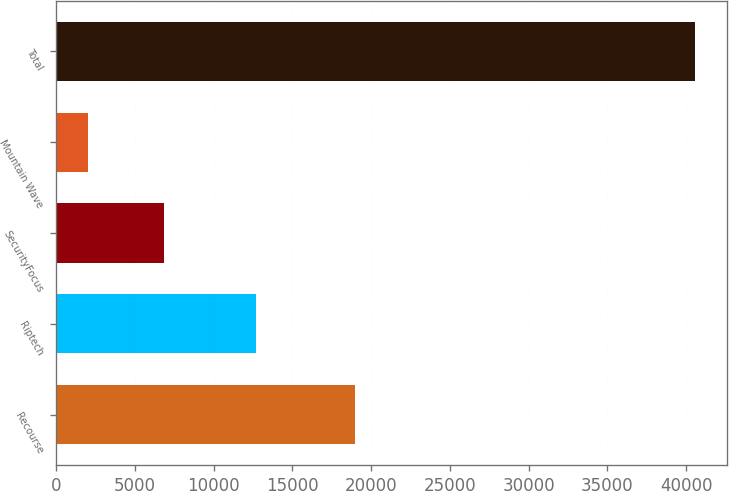Convert chart to OTSL. <chart><loc_0><loc_0><loc_500><loc_500><bar_chart><fcel>Recourse<fcel>Riptech<fcel>SecurityFocus<fcel>Mountain Wave<fcel>Total<nl><fcel>19000<fcel>12700<fcel>6840<fcel>2000<fcel>40540<nl></chart> 